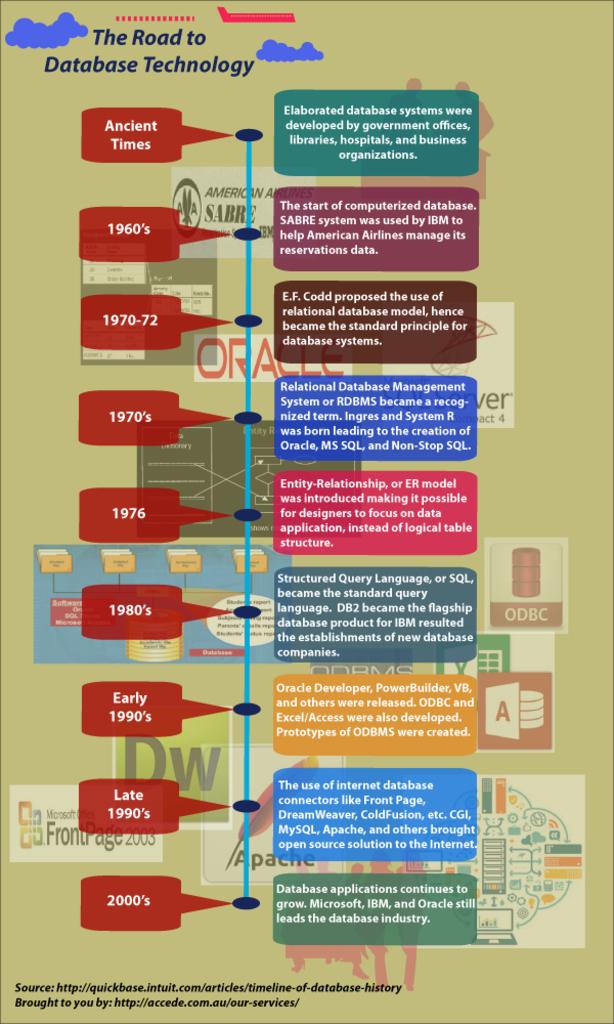What is the name of this chart?
Provide a short and direct response. The road to database technology. 